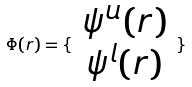<formula> <loc_0><loc_0><loc_500><loc_500>\Phi ( r ) = \{ \begin{array} { c } \psi ^ { u } ( r ) \\ \psi ^ { l } ( r ) \end{array} \}</formula> 